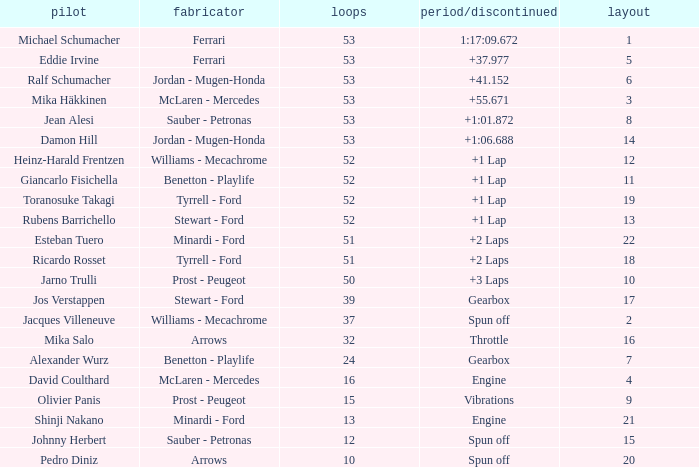What is the grid total for ralf schumacher racing over 53 laps? None. Can you give me this table as a dict? {'header': ['pilot', 'fabricator', 'loops', 'period/discontinued', 'layout'], 'rows': [['Michael Schumacher', 'Ferrari', '53', '1:17:09.672', '1'], ['Eddie Irvine', 'Ferrari', '53', '+37.977', '5'], ['Ralf Schumacher', 'Jordan - Mugen-Honda', '53', '+41.152', '6'], ['Mika Häkkinen', 'McLaren - Mercedes', '53', '+55.671', '3'], ['Jean Alesi', 'Sauber - Petronas', '53', '+1:01.872', '8'], ['Damon Hill', 'Jordan - Mugen-Honda', '53', '+1:06.688', '14'], ['Heinz-Harald Frentzen', 'Williams - Mecachrome', '52', '+1 Lap', '12'], ['Giancarlo Fisichella', 'Benetton - Playlife', '52', '+1 Lap', '11'], ['Toranosuke Takagi', 'Tyrrell - Ford', '52', '+1 Lap', '19'], ['Rubens Barrichello', 'Stewart - Ford', '52', '+1 Lap', '13'], ['Esteban Tuero', 'Minardi - Ford', '51', '+2 Laps', '22'], ['Ricardo Rosset', 'Tyrrell - Ford', '51', '+2 Laps', '18'], ['Jarno Trulli', 'Prost - Peugeot', '50', '+3 Laps', '10'], ['Jos Verstappen', 'Stewart - Ford', '39', 'Gearbox', '17'], ['Jacques Villeneuve', 'Williams - Mecachrome', '37', 'Spun off', '2'], ['Mika Salo', 'Arrows', '32', 'Throttle', '16'], ['Alexander Wurz', 'Benetton - Playlife', '24', 'Gearbox', '7'], ['David Coulthard', 'McLaren - Mercedes', '16', 'Engine', '4'], ['Olivier Panis', 'Prost - Peugeot', '15', 'Vibrations', '9'], ['Shinji Nakano', 'Minardi - Ford', '13', 'Engine', '21'], ['Johnny Herbert', 'Sauber - Petronas', '12', 'Spun off', '15'], ['Pedro Diniz', 'Arrows', '10', 'Spun off', '20']]} 